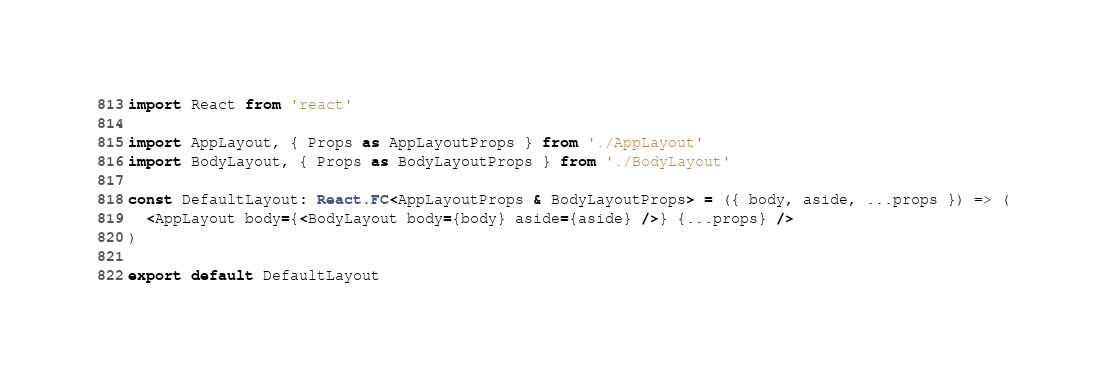<code> <loc_0><loc_0><loc_500><loc_500><_TypeScript_>import React from 'react'

import AppLayout, { Props as AppLayoutProps } from './AppLayout'
import BodyLayout, { Props as BodyLayoutProps } from './BodyLayout'

const DefaultLayout: React.FC<AppLayoutProps & BodyLayoutProps> = ({ body, aside, ...props }) => (
  <AppLayout body={<BodyLayout body={body} aside={aside} />} {...props} />
)

export default DefaultLayout
</code> 